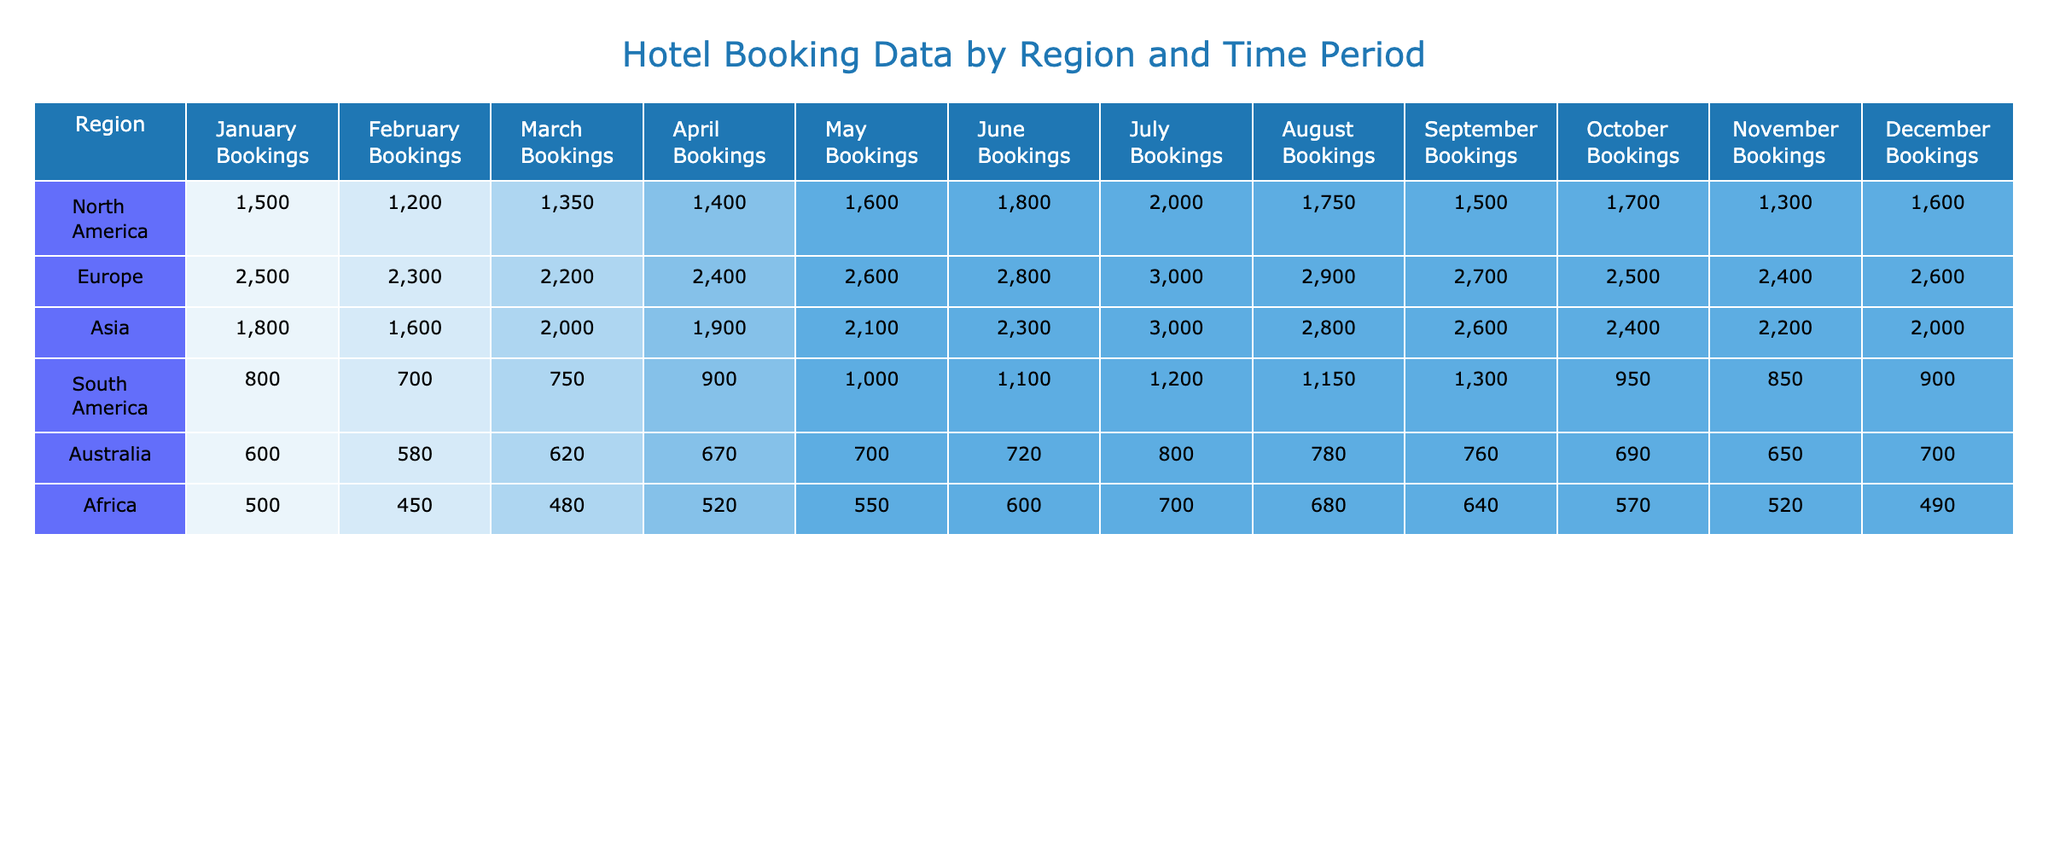What region had the highest number of bookings in July? By looking at the table, I can see the booking figures for July in each region: North America (2000), Europe (3000), Asia (3000), South America (1200), Australia (800), and Africa (700). Comparing these figures, both Europe and Asia tie for the highest bookings at 3000.
Answer: Europe and Asia Which region had the lowest bookings in December? In December, the booking numbers are North America (1600), Europe (2600), Asia (2000), South America (900), Australia (700), and Africa (490). The lowest value is found in Africa at 490.
Answer: Africa What is the total number of bookings in North America for the first half of the year? The bookings for North America from January to June are 1500, 1200, 1350, 1400, 1600, and 1800. Adding these gives a total of 1500 + 1200 + 1350 + 1400 + 1600 + 1800 = 10050.
Answer: 10050 Did South America have more bookings in April than in March? In April, South America had 900 bookings, and in March, it had 750. Comparing these two numbers, 900 is greater than 750, so the statement is true.
Answer: Yes What is the average number of bookings in Asia across the entire year? The bookings in Asia for the months are: January (1800), February (1600), March (2000), April (1900), May (2100), June (2300), July (3000), August (2800), September (2600), October (2400), November (2200), December (2000). First, sum all these values: 1800 + 1600 + 2000 + 1900 + 2100 + 2300 + 3000 + 2800 + 2600 + 2400 + 2200 + 2000 = 24500. Then, divide by 12 months: 24500 / 12 = 2041.67.
Answer: 2041.67 How much higher were bookings in Europe compared to Australia in June? The bookings for Europe in June totaled 2800, whereas for Australia they were 720. To find the difference, subtract Australia's figure from Europe's: 2800 - 720 = 2080.
Answer: 2080 